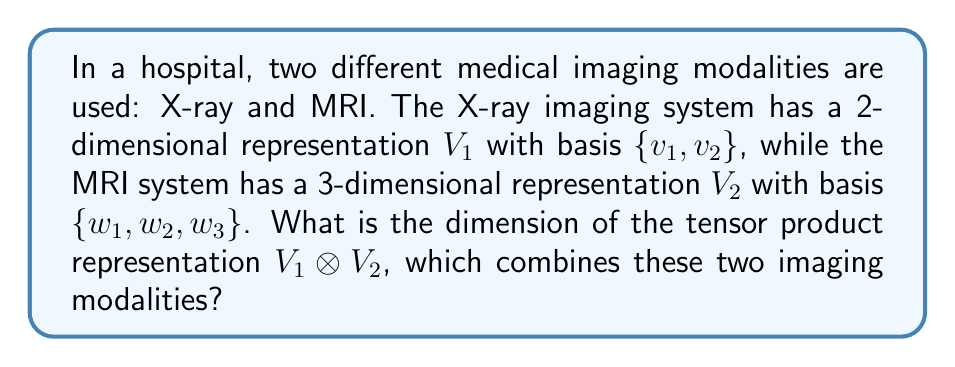Provide a solution to this math problem. To solve this problem, we'll follow these steps:

1) Recall that for vector spaces $V_1$ and $V_2$, the dimension of their tensor product is given by:

   $$\dim(V_1 \otimes V_2) = \dim(V_1) \times \dim(V_2)$$

2) In this case:
   - $\dim(V_1) = 2$ (X-ray representation)
   - $\dim(V_2) = 3$ (MRI representation)

3) Applying the formula:

   $$\dim(V_1 \otimes V_2) = 2 \times 3 = 6$$

4) To understand this intuitively, the basis of $V_1 \otimes V_2$ will consist of all possible tensor products of basis vectors from $V_1$ and $V_2$:

   $\{v_1 \otimes w_1, v_1 \otimes w_2, v_1 \otimes w_3, v_2 \otimes w_1, v_2 \otimes w_2, v_2 \otimes w_3\}$

   Which indeed gives us 6 basis vectors for the tensor product space.

5) Therefore, the dimension of the tensor product representation, which combines the X-ray and MRI modalities, is 6.
Answer: 6 